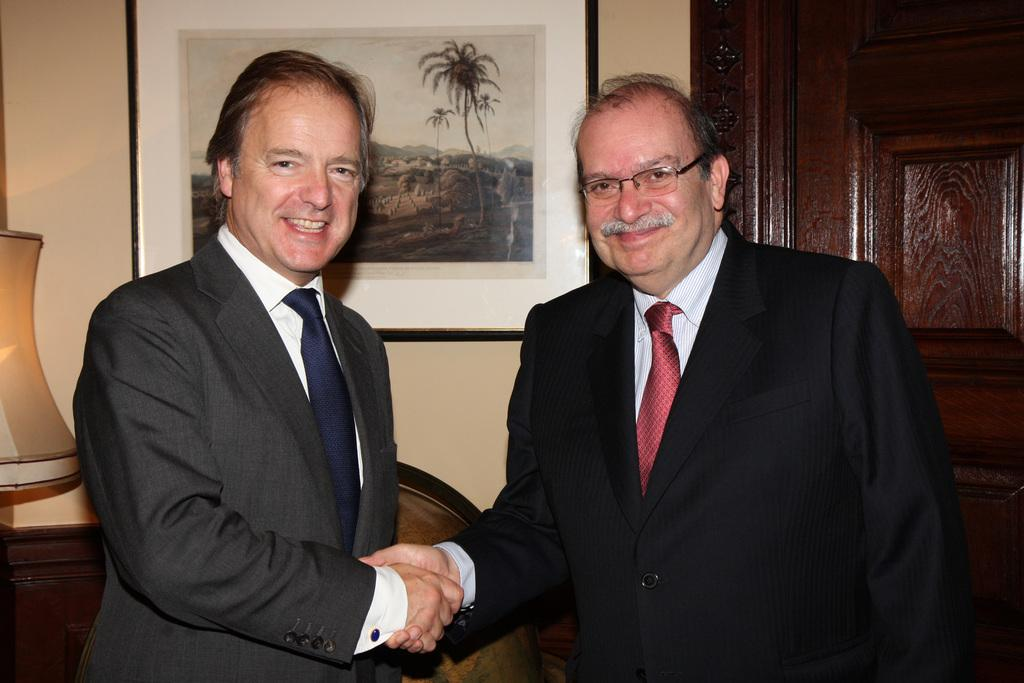How many people are in the image? There are two people in the image. What are the two people doing? The two people are shaking hands. What expressions do the people have on their faces? Both people have a smile on their face. What can be seen in the background of the image? There is a lamp, a photo frame on the wall, and a door in the background of the image. Can you see a crown on the head of either person in the image? No, there is no crown present on the heads of either person in the image. 